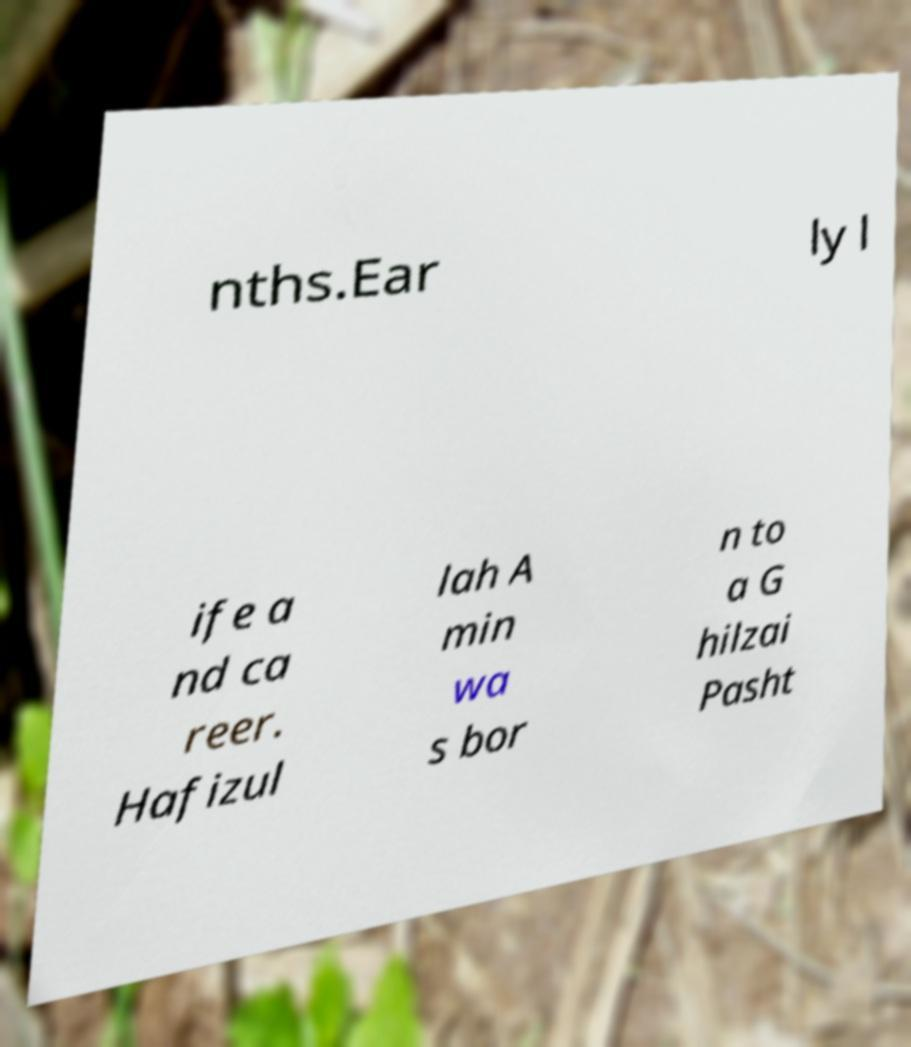I need the written content from this picture converted into text. Can you do that? nths.Ear ly l ife a nd ca reer. Hafizul lah A min wa s bor n to a G hilzai Pasht 